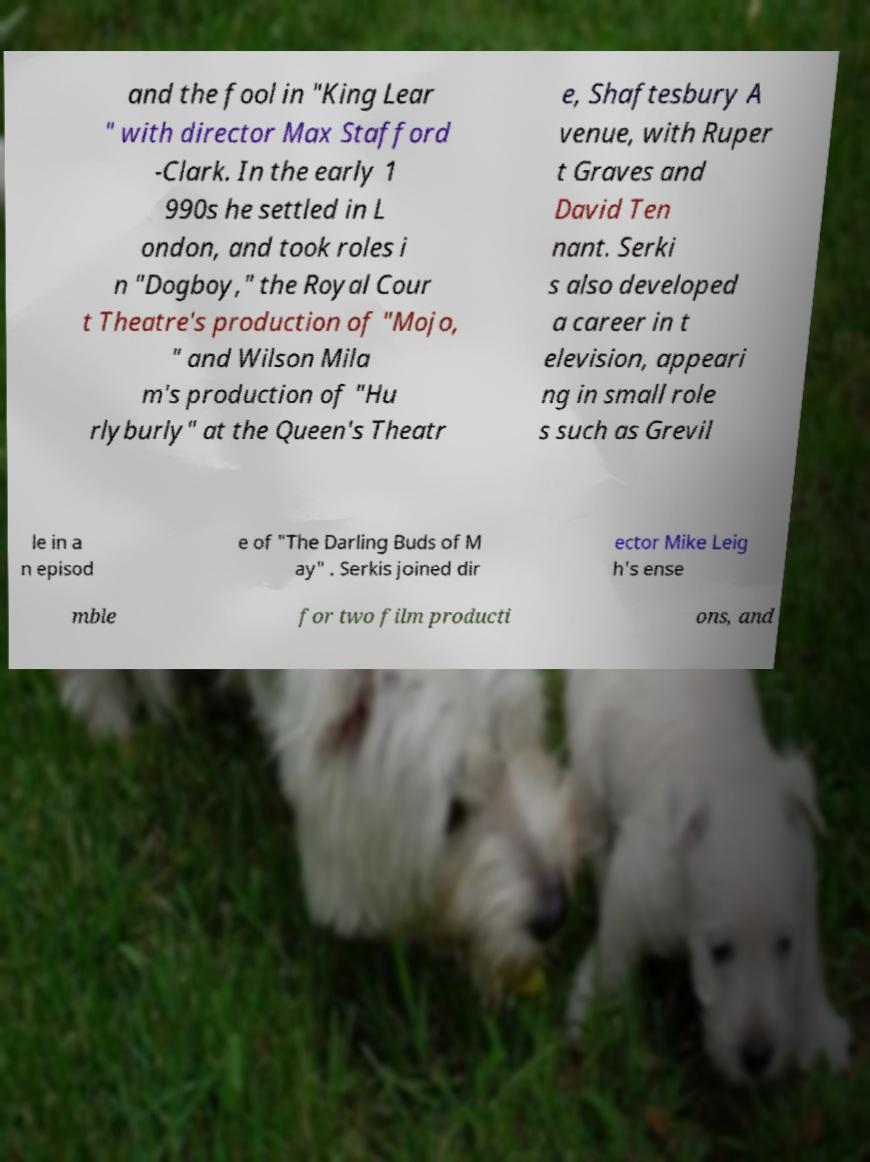I need the written content from this picture converted into text. Can you do that? and the fool in "King Lear " with director Max Stafford -Clark. In the early 1 990s he settled in L ondon, and took roles i n "Dogboy," the Royal Cour t Theatre's production of "Mojo, " and Wilson Mila m's production of "Hu rlyburly" at the Queen's Theatr e, Shaftesbury A venue, with Ruper t Graves and David Ten nant. Serki s also developed a career in t elevision, appeari ng in small role s such as Grevil le in a n episod e of "The Darling Buds of M ay" . Serkis joined dir ector Mike Leig h's ense mble for two film producti ons, and 